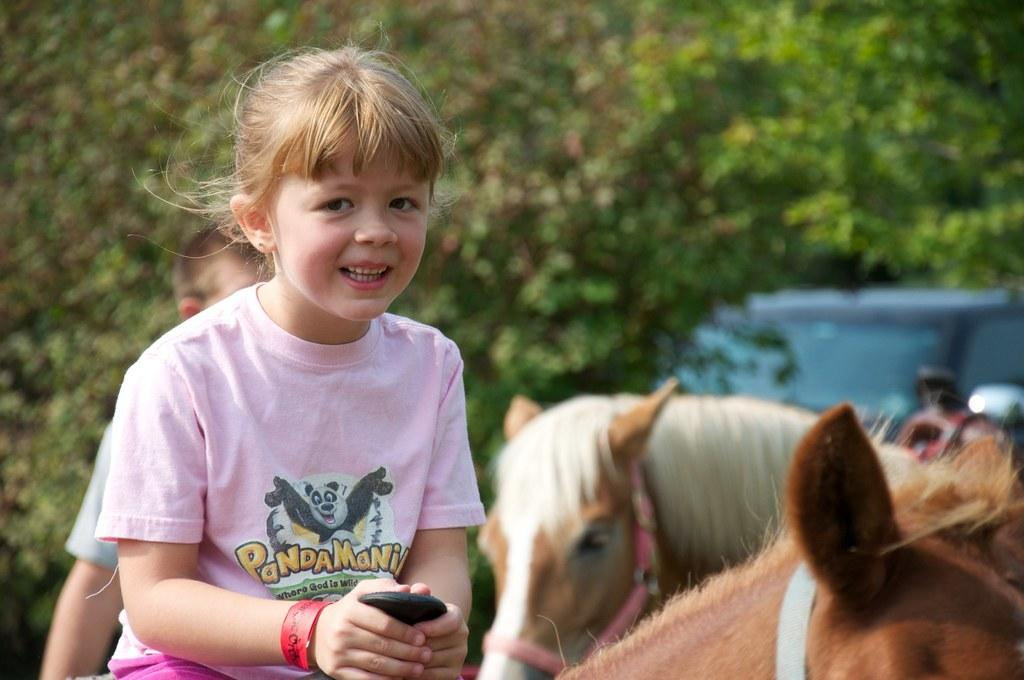What is the girl doing in the image? The girl is seated on a horse in the image. Who else is on the horse with the girl? There is a boy on the back of the horse. Are there any other horses visible in the image? Yes, there is another horse visible in the image. What type of coat is the girl wearing in the image? There is no mention of a coat in the image, as the focus is on the girl and boy riding horses. 